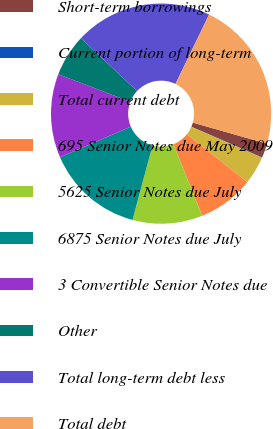Convert chart to OTSL. <chart><loc_0><loc_0><loc_500><loc_500><pie_chart><fcel>Short-term borrowings<fcel>Current portion of long-term<fcel>Total current debt<fcel>695 Senior Notes due May 2009<fcel>5625 Senior Notes due July<fcel>6875 Senior Notes due July<fcel>3 Convertible Senior Notes due<fcel>Other<fcel>Total long-term debt less<fcel>Total debt<nl><fcel>2.1%<fcel>0.06%<fcel>4.14%<fcel>8.22%<fcel>10.26%<fcel>14.34%<fcel>12.3%<fcel>6.18%<fcel>20.18%<fcel>22.22%<nl></chart> 